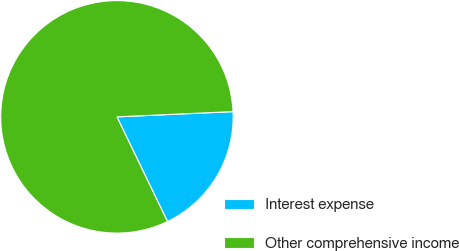Convert chart. <chart><loc_0><loc_0><loc_500><loc_500><pie_chart><fcel>Interest expense<fcel>Other comprehensive income<nl><fcel>18.56%<fcel>81.44%<nl></chart> 